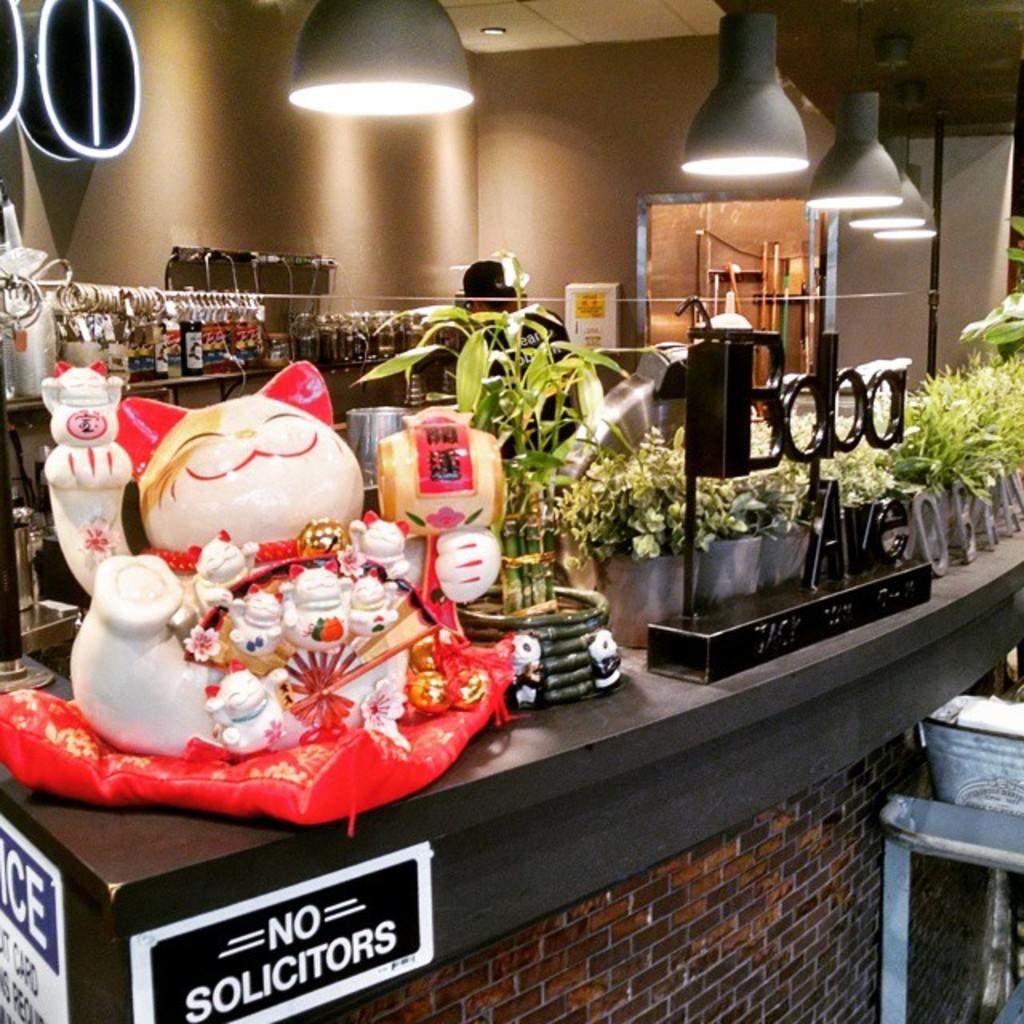<image>
Summarize the visual content of the image. a table that has no solicitors on it 